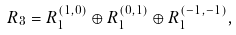Convert formula to latex. <formula><loc_0><loc_0><loc_500><loc_500>R _ { 3 } = R _ { 1 } ^ { ( 1 , 0 ) } \oplus R _ { 1 } ^ { ( 0 , 1 ) } \oplus R _ { 1 } ^ { ( - 1 , - 1 ) } ,</formula> 